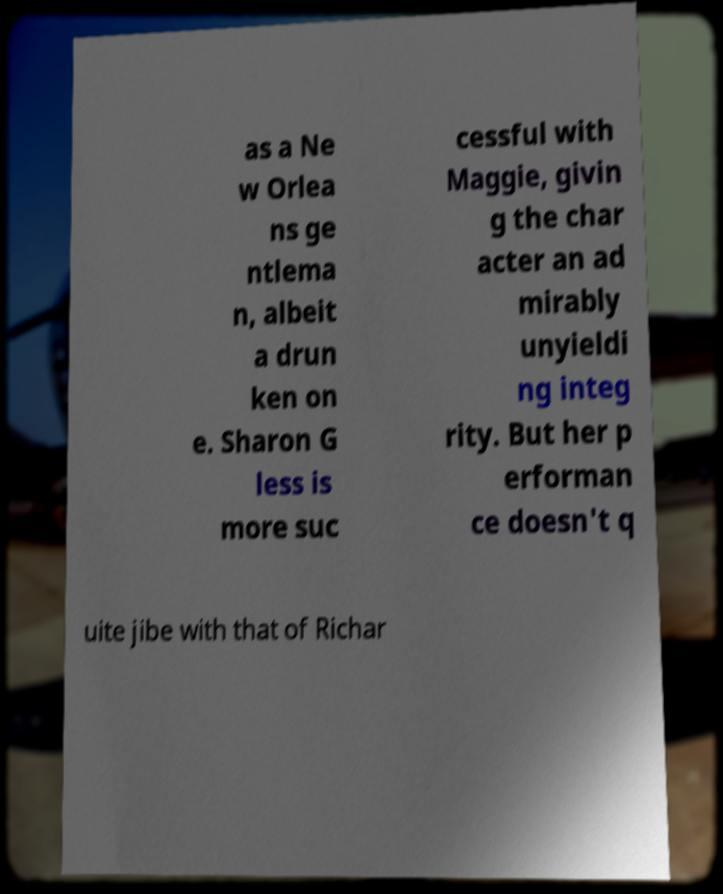There's text embedded in this image that I need extracted. Can you transcribe it verbatim? as a Ne w Orlea ns ge ntlema n, albeit a drun ken on e. Sharon G less is more suc cessful with Maggie, givin g the char acter an ad mirably unyieldi ng integ rity. But her p erforman ce doesn't q uite jibe with that of Richar 